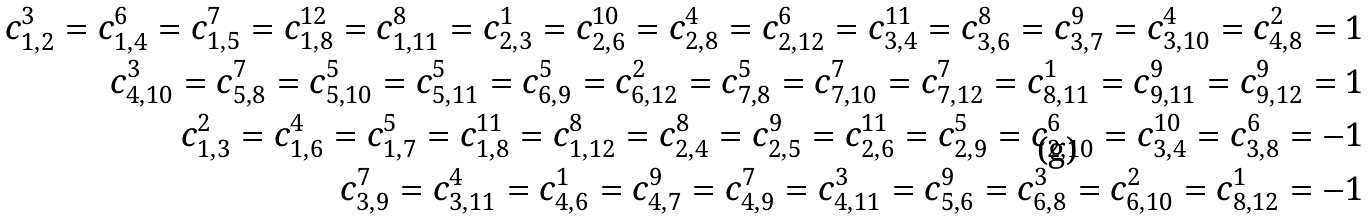<formula> <loc_0><loc_0><loc_500><loc_500>c _ { 1 , 2 } ^ { 3 } = c _ { 1 , 4 } ^ { 6 } = c _ { 1 , 5 } ^ { 7 } = c _ { 1 , 8 } ^ { 1 2 } = c _ { 1 , 1 1 } ^ { 8 } = c _ { 2 , 3 } ^ { 1 } = c _ { 2 , 6 } ^ { 1 0 } = c _ { 2 , 8 } ^ { 4 } = c _ { 2 , 1 2 } ^ { 6 } = c _ { 3 , 4 } ^ { 1 1 } = c _ { 3 , 6 } ^ { 8 } = c _ { 3 , 7 } ^ { 9 } = c _ { 3 , 1 0 } ^ { 4 } = c _ { 4 , 8 } ^ { 2 } = 1 \\ c _ { 4 , 1 0 } ^ { 3 } = c _ { 5 , 8 } ^ { 7 } = c _ { 5 , 1 0 } ^ { 5 } = c _ { 5 , 1 1 } ^ { 5 } = c _ { 6 , 9 } ^ { 5 } = c _ { 6 , 1 2 } ^ { 2 } = c _ { 7 , 8 } ^ { 5 } = c _ { 7 , 1 0 } ^ { 7 } = c _ { 7 , 1 2 } ^ { 7 } = c _ { 8 , 1 1 } ^ { 1 } = c _ { 9 , 1 1 } ^ { 9 } = c _ { 9 , 1 2 } ^ { 9 } = 1 \\ c _ { 1 , 3 } ^ { 2 } = c _ { 1 , 6 } ^ { 4 } = c _ { 1 , 7 } ^ { 5 } = c _ { 1 , 8 } ^ { 1 1 } = c _ { 1 , 1 2 } ^ { 8 } = c _ { 2 , 4 } ^ { 8 } = c _ { 2 , 5 } ^ { 9 } = c _ { 2 , 6 } ^ { 1 1 } = c _ { 2 , 9 } ^ { 5 } = c _ { 2 , 1 0 } ^ { 6 } = c _ { 3 , 4 } ^ { 1 0 } = c _ { 3 , 8 } ^ { 6 } = - 1 \\ c _ { 3 , 9 } ^ { 7 } = c _ { 3 , 1 1 } ^ { 4 } = c _ { 4 , 6 } ^ { 1 } = c _ { 4 , 7 } ^ { 9 } = c _ { 4 , 9 } ^ { 7 } = c _ { 4 , 1 1 } ^ { 3 } = c _ { 5 , 6 } ^ { 9 } = c _ { 6 , 8 } ^ { 3 } = c _ { 6 , 1 0 } ^ { 2 } = c _ { 8 , 1 2 } ^ { 1 } = - 1</formula> 